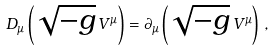<formula> <loc_0><loc_0><loc_500><loc_500>D _ { \mu } \left ( \sqrt { - g } \, V ^ { \mu } \right ) = \partial _ { \mu } \left ( \sqrt { - g } \, V ^ { \mu } \right ) \, ,</formula> 